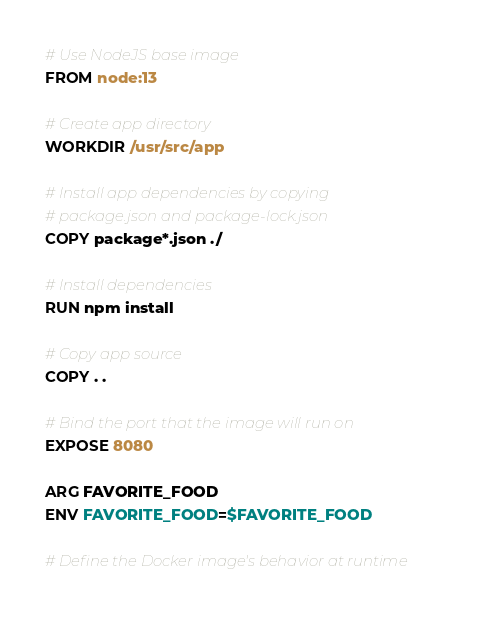<code> <loc_0><loc_0><loc_500><loc_500><_Dockerfile_># Use NodeJS base image
FROM node:13

# Create app directory
WORKDIR /usr/src/app

# Install app dependencies by copying
# package.json and package-lock.json
COPY package*.json ./

# Install dependencies
RUN npm install

# Copy app source
COPY . .

# Bind the port that the image will run on
EXPOSE 8080

ARG FAVORITE_FOOD
ENV FAVORITE_FOOD=$FAVORITE_FOOD

# Define the Docker image's behavior at runtime</code> 